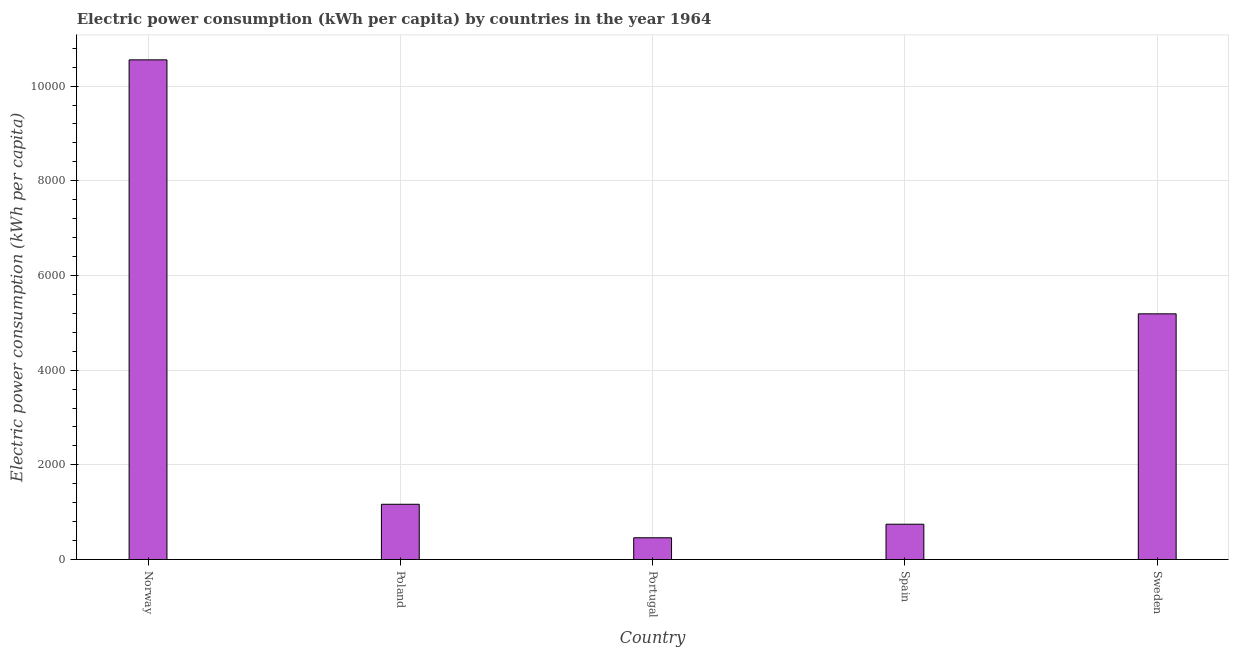Does the graph contain any zero values?
Offer a very short reply. No. What is the title of the graph?
Your answer should be compact. Electric power consumption (kWh per capita) by countries in the year 1964. What is the label or title of the X-axis?
Your response must be concise. Country. What is the label or title of the Y-axis?
Provide a succinct answer. Electric power consumption (kWh per capita). What is the electric power consumption in Spain?
Keep it short and to the point. 745.38. Across all countries, what is the maximum electric power consumption?
Give a very brief answer. 1.06e+04. Across all countries, what is the minimum electric power consumption?
Offer a very short reply. 459.53. In which country was the electric power consumption maximum?
Provide a short and direct response. Norway. What is the sum of the electric power consumption?
Your response must be concise. 1.81e+04. What is the difference between the electric power consumption in Poland and Portugal?
Ensure brevity in your answer.  707.51. What is the average electric power consumption per country?
Offer a very short reply. 3622.94. What is the median electric power consumption?
Your response must be concise. 1167.04. In how many countries, is the electric power consumption greater than 6800 kWh per capita?
Offer a very short reply. 1. What is the ratio of the electric power consumption in Spain to that in Sweden?
Offer a terse response. 0.14. Is the difference between the electric power consumption in Norway and Spain greater than the difference between any two countries?
Make the answer very short. No. What is the difference between the highest and the second highest electric power consumption?
Your response must be concise. 5364.15. Is the sum of the electric power consumption in Portugal and Spain greater than the maximum electric power consumption across all countries?
Give a very brief answer. No. What is the difference between the highest and the lowest electric power consumption?
Your response must be concise. 1.01e+04. In how many countries, is the electric power consumption greater than the average electric power consumption taken over all countries?
Make the answer very short. 2. Are all the bars in the graph horizontal?
Provide a succinct answer. No. How many countries are there in the graph?
Offer a terse response. 5. What is the difference between two consecutive major ticks on the Y-axis?
Make the answer very short. 2000. Are the values on the major ticks of Y-axis written in scientific E-notation?
Ensure brevity in your answer.  No. What is the Electric power consumption (kWh per capita) in Norway?
Offer a terse response. 1.06e+04. What is the Electric power consumption (kWh per capita) of Poland?
Offer a very short reply. 1167.04. What is the Electric power consumption (kWh per capita) of Portugal?
Provide a short and direct response. 459.53. What is the Electric power consumption (kWh per capita) in Spain?
Provide a succinct answer. 745.38. What is the Electric power consumption (kWh per capita) in Sweden?
Keep it short and to the point. 5189.29. What is the difference between the Electric power consumption (kWh per capita) in Norway and Poland?
Provide a short and direct response. 9386.4. What is the difference between the Electric power consumption (kWh per capita) in Norway and Portugal?
Make the answer very short. 1.01e+04. What is the difference between the Electric power consumption (kWh per capita) in Norway and Spain?
Provide a succinct answer. 9808.06. What is the difference between the Electric power consumption (kWh per capita) in Norway and Sweden?
Ensure brevity in your answer.  5364.15. What is the difference between the Electric power consumption (kWh per capita) in Poland and Portugal?
Your answer should be very brief. 707.51. What is the difference between the Electric power consumption (kWh per capita) in Poland and Spain?
Your response must be concise. 421.66. What is the difference between the Electric power consumption (kWh per capita) in Poland and Sweden?
Your answer should be compact. -4022.25. What is the difference between the Electric power consumption (kWh per capita) in Portugal and Spain?
Ensure brevity in your answer.  -285.86. What is the difference between the Electric power consumption (kWh per capita) in Portugal and Sweden?
Give a very brief answer. -4729.76. What is the difference between the Electric power consumption (kWh per capita) in Spain and Sweden?
Your response must be concise. -4443.91. What is the ratio of the Electric power consumption (kWh per capita) in Norway to that in Poland?
Your answer should be very brief. 9.04. What is the ratio of the Electric power consumption (kWh per capita) in Norway to that in Portugal?
Give a very brief answer. 22.97. What is the ratio of the Electric power consumption (kWh per capita) in Norway to that in Spain?
Ensure brevity in your answer.  14.16. What is the ratio of the Electric power consumption (kWh per capita) in Norway to that in Sweden?
Make the answer very short. 2.03. What is the ratio of the Electric power consumption (kWh per capita) in Poland to that in Portugal?
Make the answer very short. 2.54. What is the ratio of the Electric power consumption (kWh per capita) in Poland to that in Spain?
Offer a terse response. 1.57. What is the ratio of the Electric power consumption (kWh per capita) in Poland to that in Sweden?
Provide a short and direct response. 0.23. What is the ratio of the Electric power consumption (kWh per capita) in Portugal to that in Spain?
Provide a short and direct response. 0.62. What is the ratio of the Electric power consumption (kWh per capita) in Portugal to that in Sweden?
Make the answer very short. 0.09. What is the ratio of the Electric power consumption (kWh per capita) in Spain to that in Sweden?
Your answer should be very brief. 0.14. 